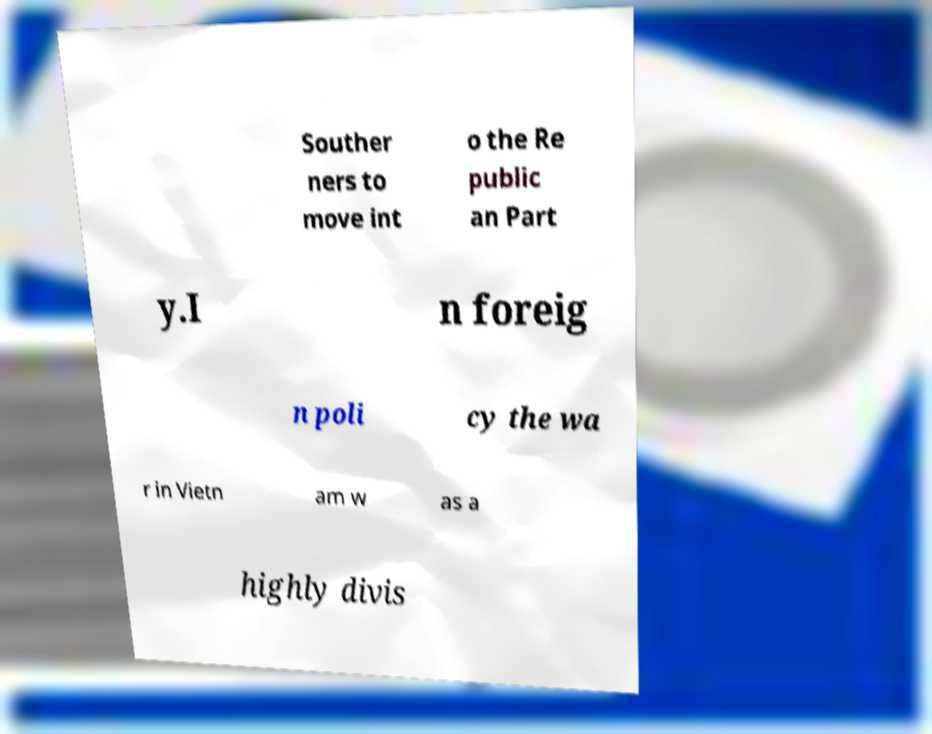Could you assist in decoding the text presented in this image and type it out clearly? Souther ners to move int o the Re public an Part y.I n foreig n poli cy the wa r in Vietn am w as a highly divis 